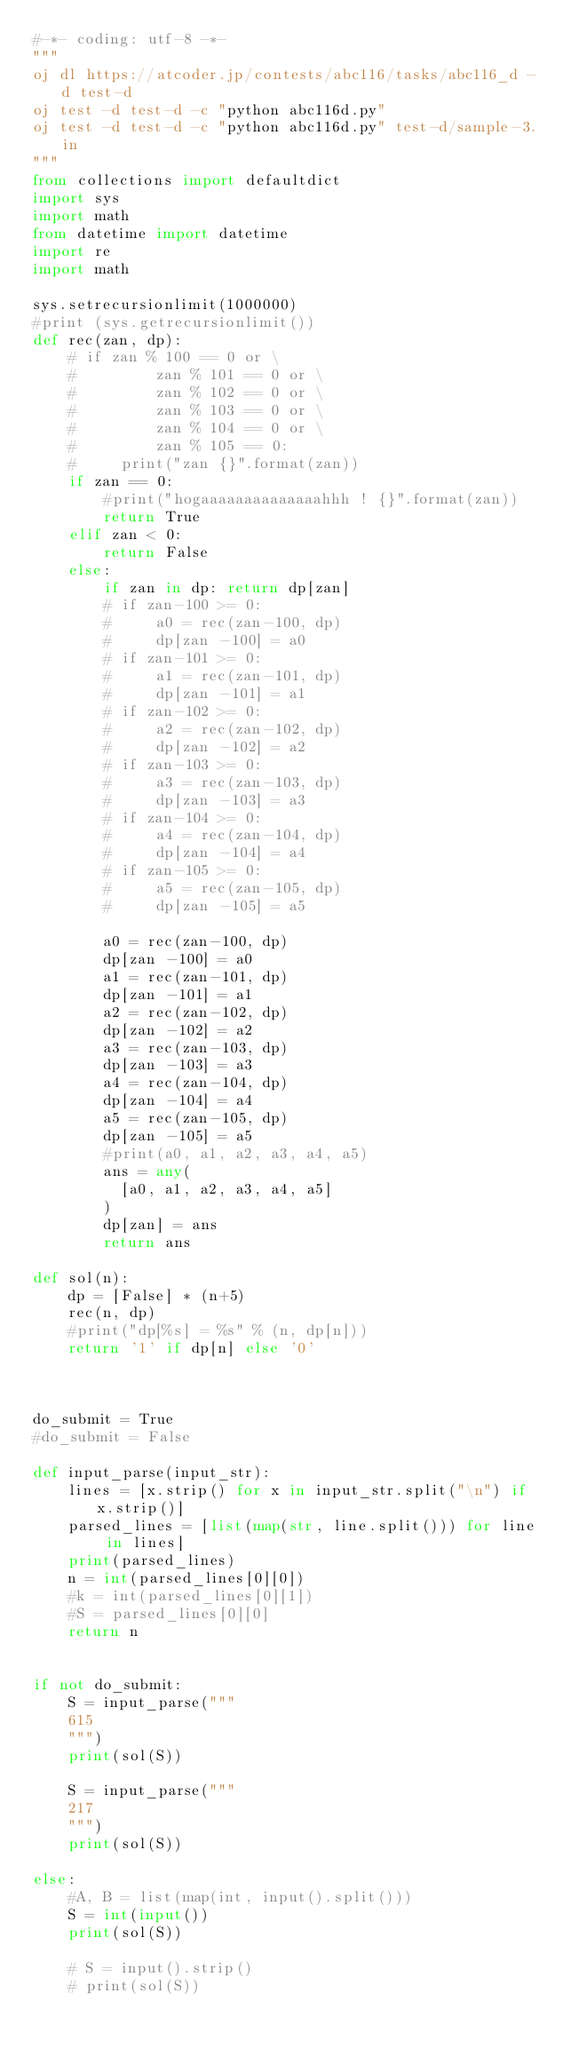<code> <loc_0><loc_0><loc_500><loc_500><_Python_>#-*- coding: utf-8 -*-
"""
oj dl https://atcoder.jp/contests/abc116/tasks/abc116_d -d test-d
oj test -d test-d -c "python abc116d.py"
oj test -d test-d -c "python abc116d.py" test-d/sample-3.in
"""
from collections import defaultdict
import sys
import math
from datetime import datetime
import re
import math

sys.setrecursionlimit(1000000)
#print (sys.getrecursionlimit())
def rec(zan, dp):
    # if zan % 100 == 0 or \
    #         zan % 101 == 0 or \
    #         zan % 102 == 0 or \
    #         zan % 103 == 0 or \
    #         zan % 104 == 0 or \
    #         zan % 105 == 0:
    #     print("zan {}".format(zan))
    if zan == 0:
        #print("hogaaaaaaaaaaaaaahhh ! {}".format(zan))
        return True
    elif zan < 0:
        return False
    else:
        if zan in dp: return dp[zan]
        # if zan-100 >= 0:
        #     a0 = rec(zan-100, dp)
        #     dp[zan -100] = a0
        # if zan-101 >= 0:
        #     a1 = rec(zan-101, dp)
        #     dp[zan -101] = a1
        # if zan-102 >= 0:
        #     a2 = rec(zan-102, dp)
        #     dp[zan -102] = a2
        # if zan-103 >= 0:
        #     a3 = rec(zan-103, dp)
        #     dp[zan -103] = a3
        # if zan-104 >= 0:
        #     a4 = rec(zan-104, dp)
        #     dp[zan -104] = a4
        # if zan-105 >= 0:
        #     a5 = rec(zan-105, dp)
        #     dp[zan -105] = a5

        a0 = rec(zan-100, dp)
        dp[zan -100] = a0
        a1 = rec(zan-101, dp)
        dp[zan -101] = a1
        a2 = rec(zan-102, dp)
        dp[zan -102] = a2
        a3 = rec(zan-103, dp)
        dp[zan -103] = a3
        a4 = rec(zan-104, dp)
        dp[zan -104] = a4
        a5 = rec(zan-105, dp)
        dp[zan -105] = a5
        #print(a0, a1, a2, a3, a4, a5)
        ans = any(
          [a0, a1, a2, a3, a4, a5]
        )
        dp[zan] = ans
        return ans

def sol(n):
    dp = [False] * (n+5)
    rec(n, dp)
    #print("dp[%s] = %s" % (n, dp[n]))
    return '1' if dp[n] else '0'



do_submit = True
#do_submit = False

def input_parse(input_str):
    lines = [x.strip() for x in input_str.split("\n") if x.strip()]
    parsed_lines = [list(map(str, line.split())) for line in lines]
    print(parsed_lines)
    n = int(parsed_lines[0][0])
    #k = int(parsed_lines[0][1])
    #S = parsed_lines[0][0]
    return n


if not do_submit:
    S = input_parse("""
    615
    """)
    print(sol(S))

    S = input_parse("""
    217
    """)
    print(sol(S))

else:
    #A, B = list(map(int, input().split()))
    S = int(input())
    print(sol(S))

    # S = input().strip()
    # print(sol(S))



</code> 